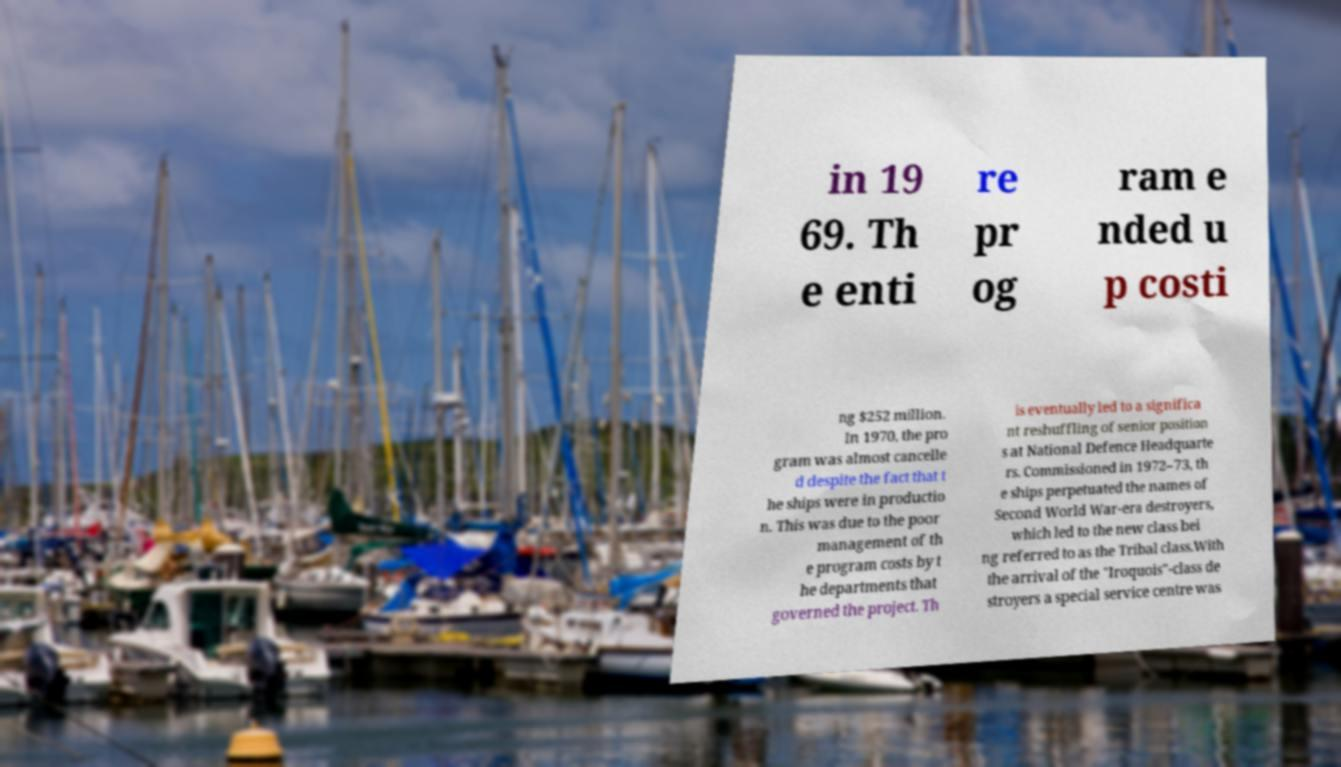Could you assist in decoding the text presented in this image and type it out clearly? in 19 69. Th e enti re pr og ram e nded u p costi ng $252 million. In 1970, the pro gram was almost cancelle d despite the fact that t he ships were in productio n. This was due to the poor management of th e program costs by t he departments that governed the project. Th is eventually led to a significa nt reshuffling of senior position s at National Defence Headquarte rs. Commissioned in 1972–73, th e ships perpetuated the names of Second World War-era destroyers, which led to the new class bei ng referred to as the Tribal class.With the arrival of the "Iroquois"-class de stroyers a special service centre was 